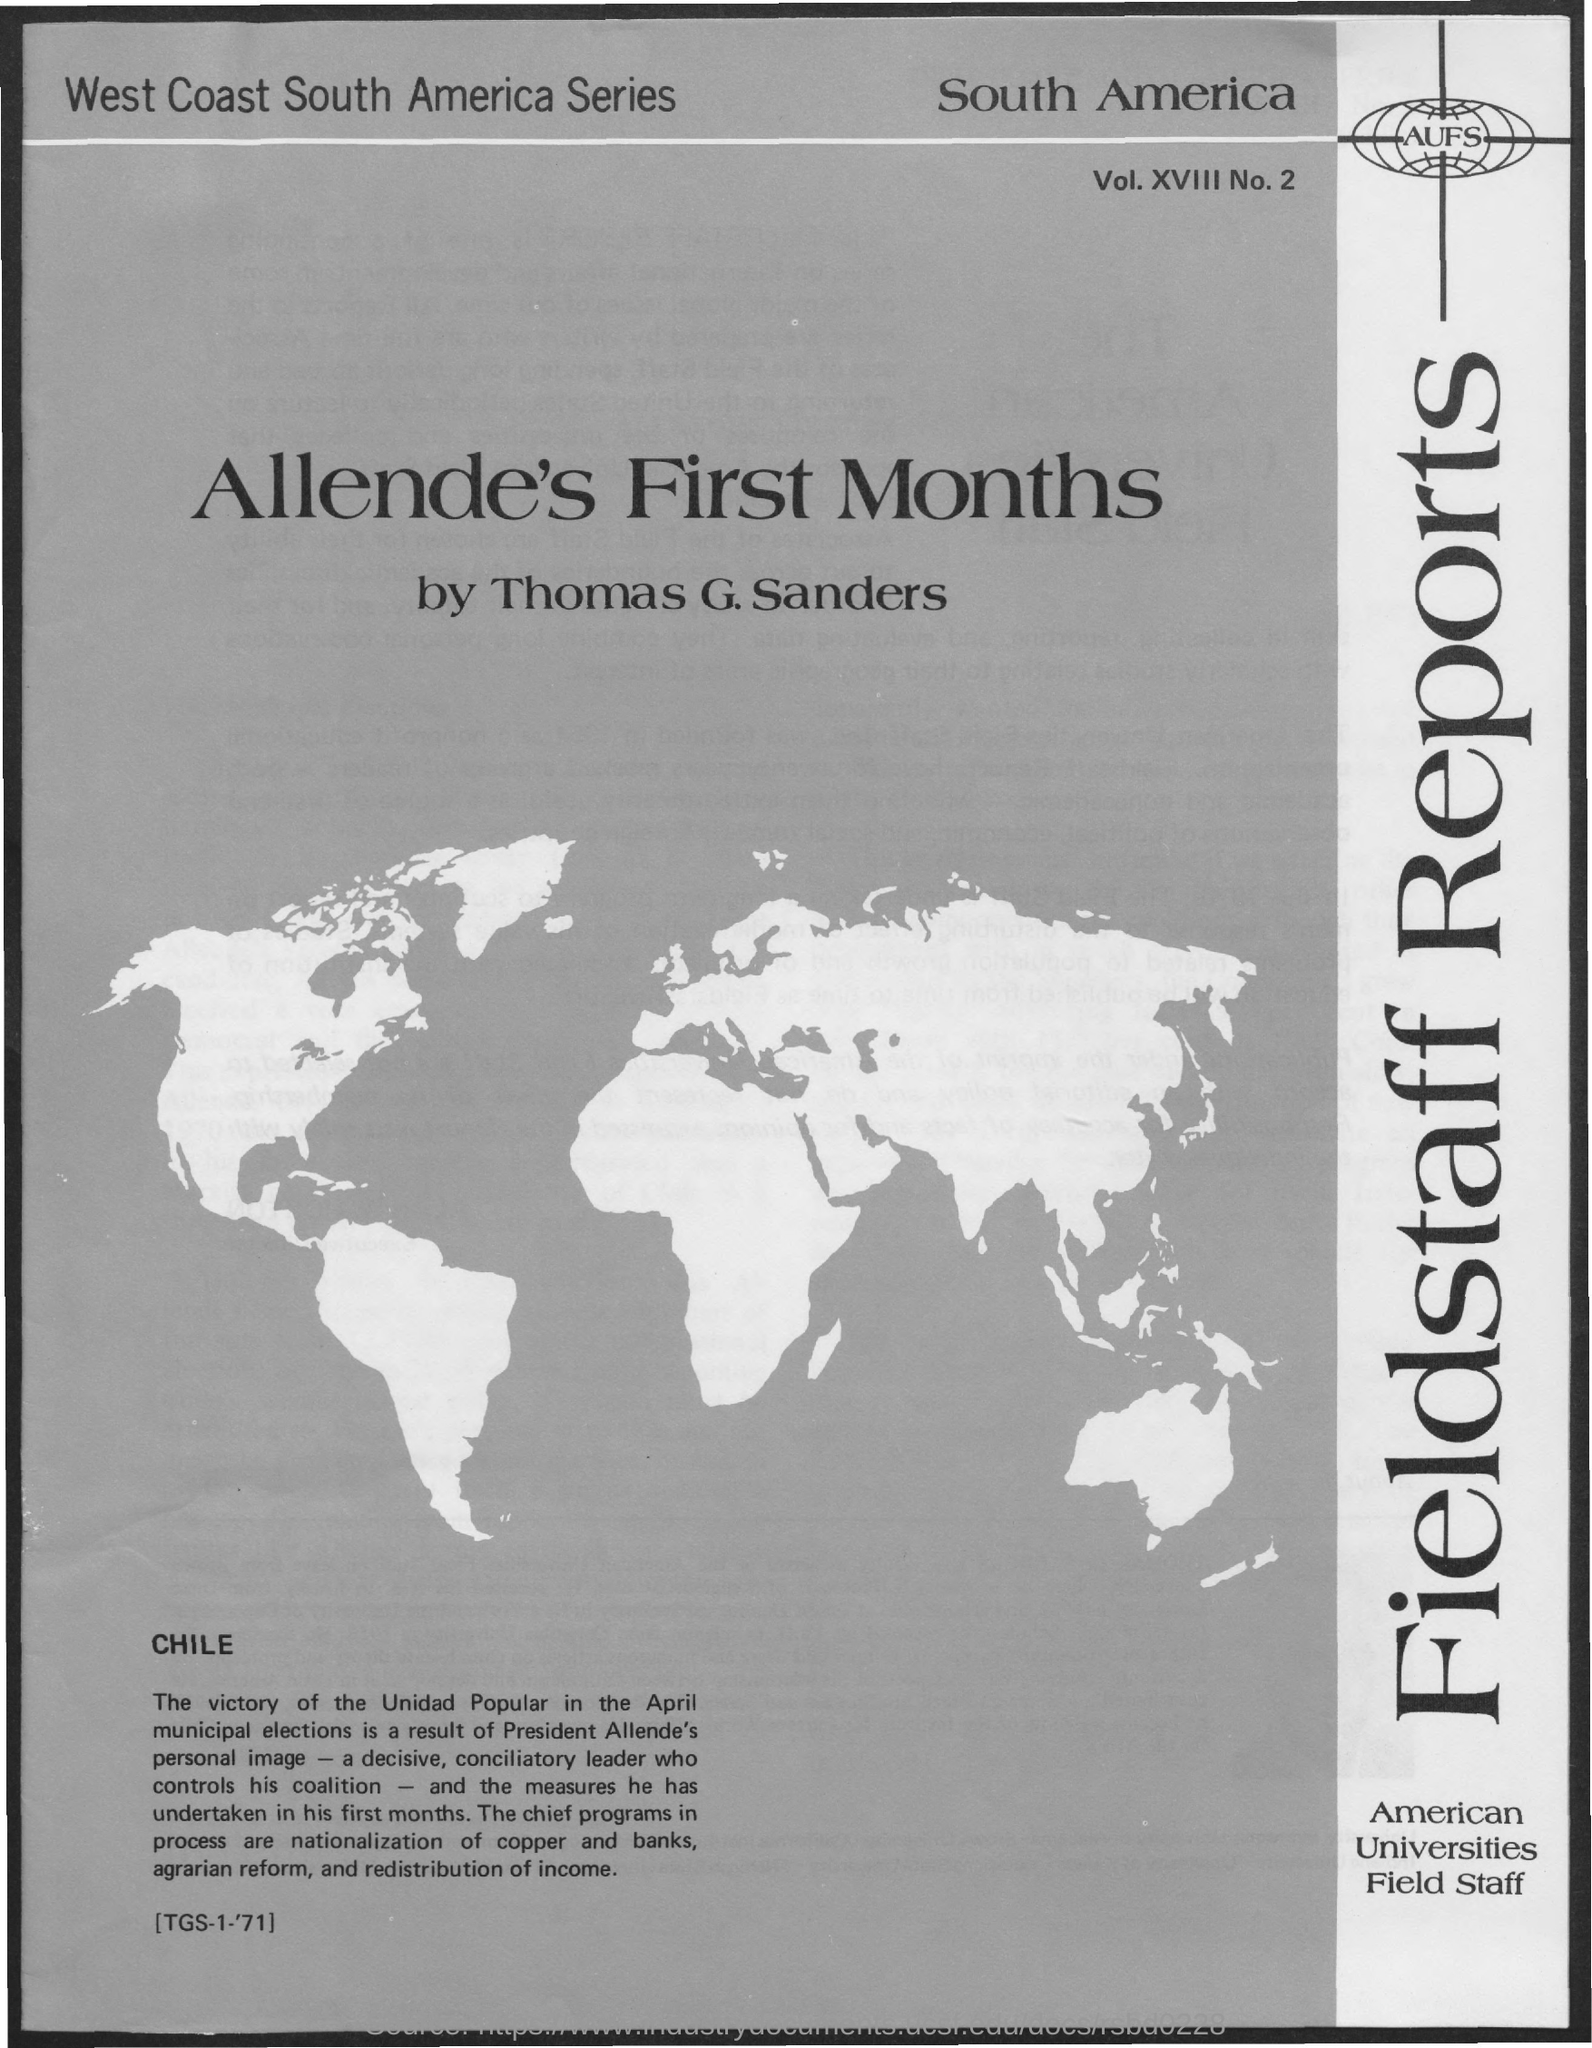Indicate a few pertinent items in this graphic. The text that is contained within the image is 'aufs..' The volume number of the publication is xviii and the number of the issue is 2. The top-left corner of the document contains the text 'West Coast South America Series.' The country located at the top-right of the document is named South America. 